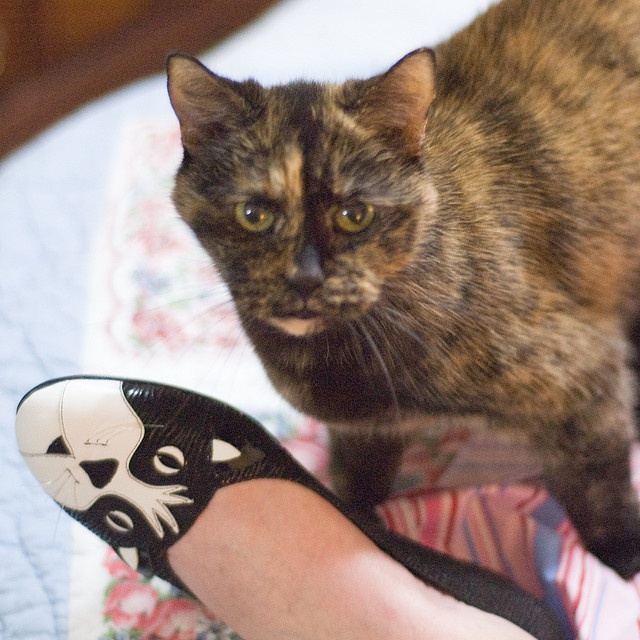Describe the objects in this image and their specific colors. I can see cat in maroon, gray, and black tones, bed in maroon, lavender, lightpink, darkgray, and lightgray tones, and people in maroon, black, tan, lightgray, and salmon tones in this image. 